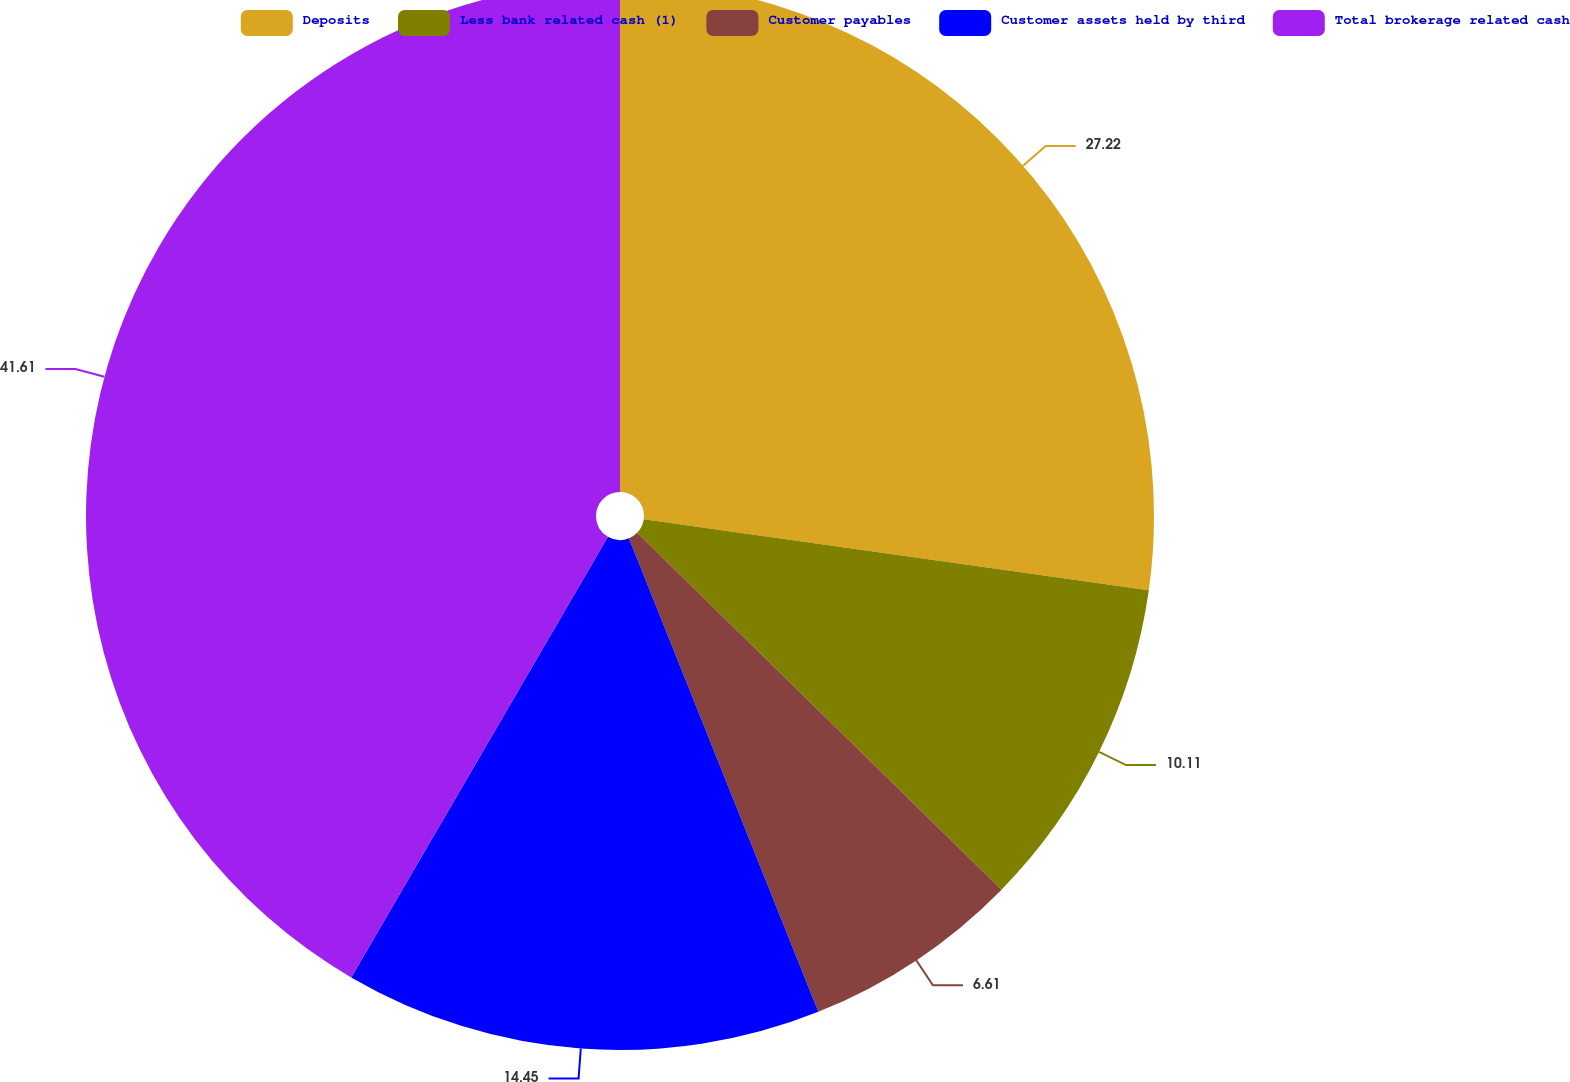<chart> <loc_0><loc_0><loc_500><loc_500><pie_chart><fcel>Deposits<fcel>Less bank related cash (1)<fcel>Customer payables<fcel>Customer assets held by third<fcel>Total brokerage related cash<nl><fcel>27.22%<fcel>10.11%<fcel>6.61%<fcel>14.45%<fcel>41.6%<nl></chart> 